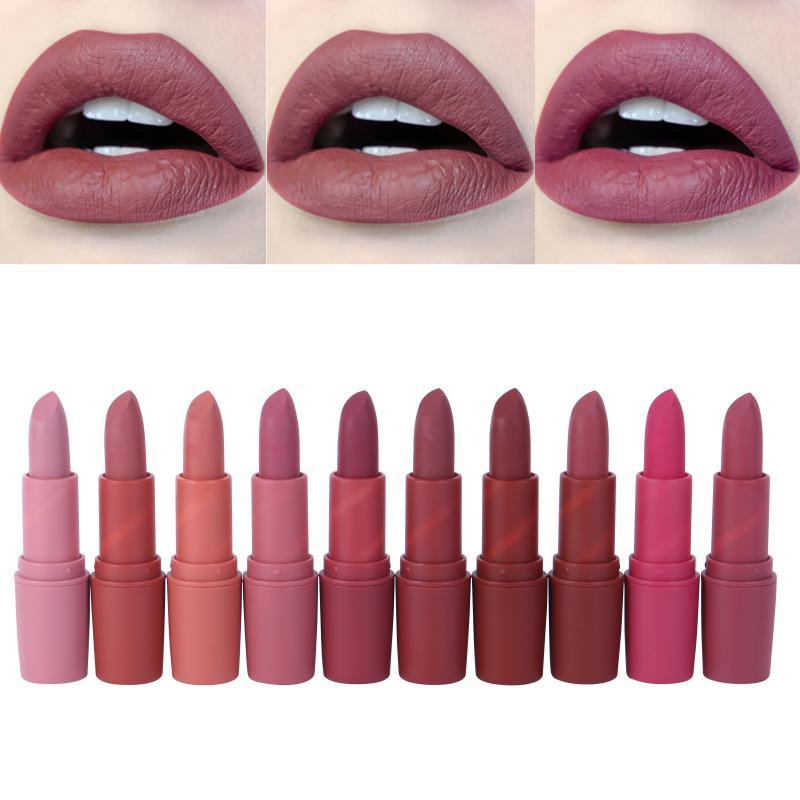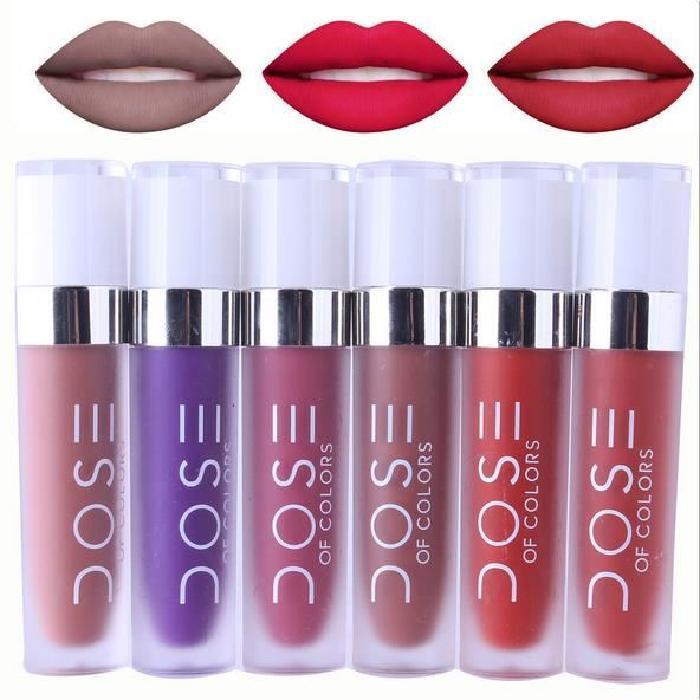The first image is the image on the left, the second image is the image on the right. Analyze the images presented: Is the assertion "At least one of the images shows exactly three mouths." valid? Answer yes or no. Yes. 